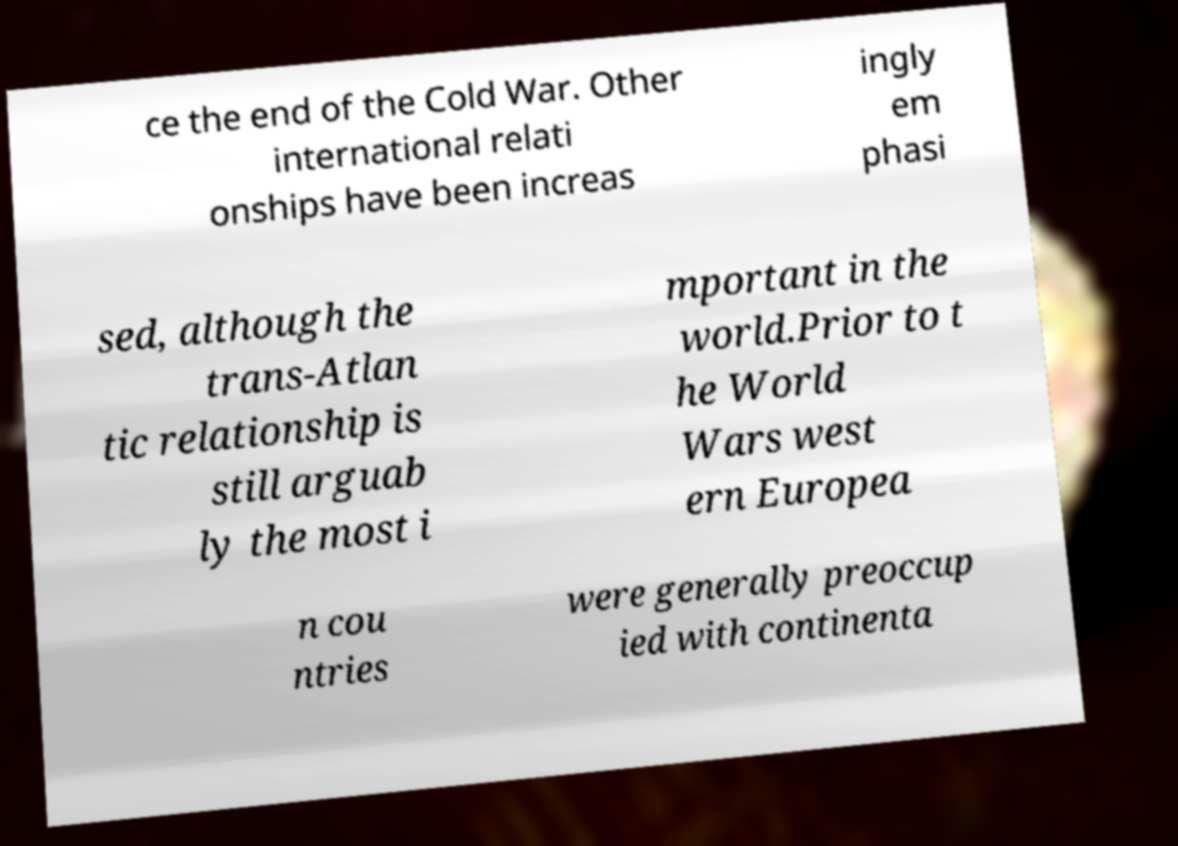Can you accurately transcribe the text from the provided image for me? ce the end of the Cold War. Other international relati onships have been increas ingly em phasi sed, although the trans-Atlan tic relationship is still arguab ly the most i mportant in the world.Prior to t he World Wars west ern Europea n cou ntries were generally preoccup ied with continenta 